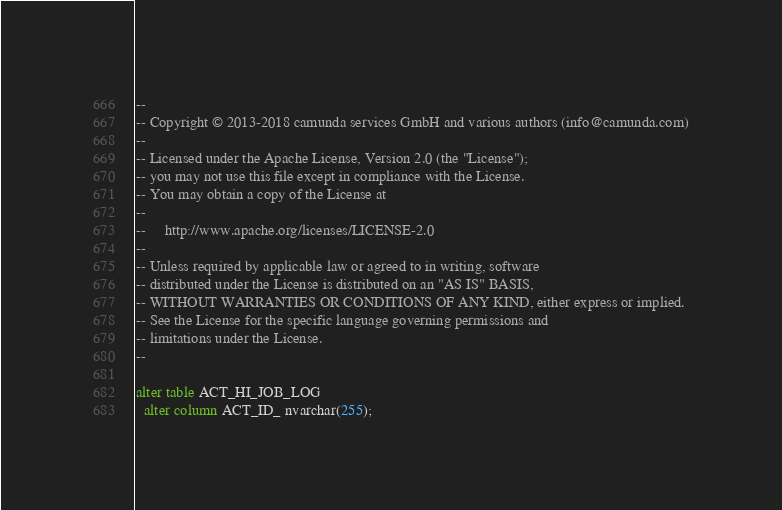Convert code to text. <code><loc_0><loc_0><loc_500><loc_500><_SQL_>--
-- Copyright © 2013-2018 camunda services GmbH and various authors (info@camunda.com)
--
-- Licensed under the Apache License, Version 2.0 (the "License");
-- you may not use this file except in compliance with the License.
-- You may obtain a copy of the License at
--
--     http://www.apache.org/licenses/LICENSE-2.0
--
-- Unless required by applicable law or agreed to in writing, software
-- distributed under the License is distributed on an "AS IS" BASIS,
-- WITHOUT WARRANTIES OR CONDITIONS OF ANY KIND, either express or implied.
-- See the License for the specific language governing permissions and
-- limitations under the License.
--

alter table ACT_HI_JOB_LOG
  alter column ACT_ID_ nvarchar(255);
</code> 